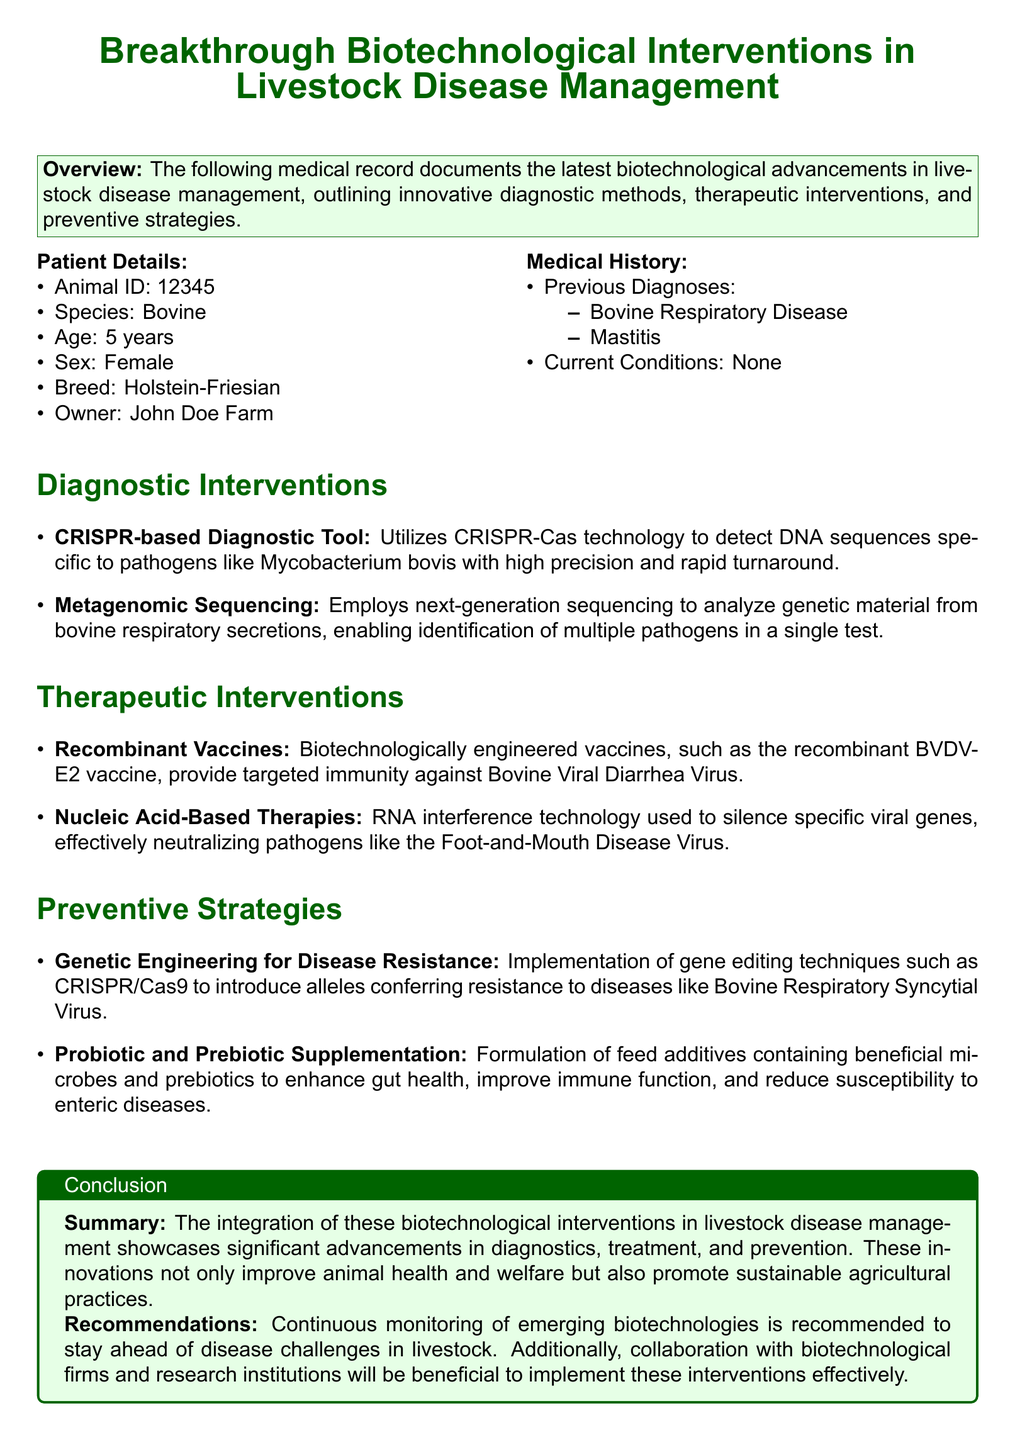What is the Animal ID? The Animal ID is listed under Patient Details, identifying the specific animal.
Answer: 12345 What is the breed of the animal? The breed is specified in the Patient Details section.
Answer: Holstein-Friesian Which disease has been previously diagnosed? The document lists previous diagnoses as part of the Medical History.
Answer: Bovine Respiratory Disease What type of diagnostic tool uses CRISPR-Cas technology? This information is found in the Diagnostic Interventions section, describing specific tools used for diagnostics.
Answer: CRISPR-based Diagnostic Tool What is one of the therapeutic interventions mentioned? Therapeutic interventions are listed under a specific section, highlighting technologies used for treatment.
Answer: Recombinant Vaccines What is the focus of the preventive strategies? The Preventive Strategies section outlines the goals of the interventions listed.
Answer: Disease Resistance How many current conditions does the animal have? The current conditions are detailed in the Medical History section.
Answer: None What is the purpose of probiotic and prebiotic supplementation? This question references the content of the Preventive Strategies section regarding animal health.
Answer: Enhance gut health What is the recommended action for farmers regarding biotechnological advancements? The recommendation is stated in the Conclusion section, suggesting how to adapt to new technologies.
Answer: Continuous monitoring 